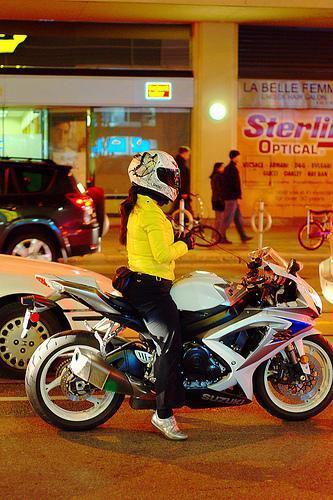How many motorcycles are there?
Give a very brief answer. 1. 